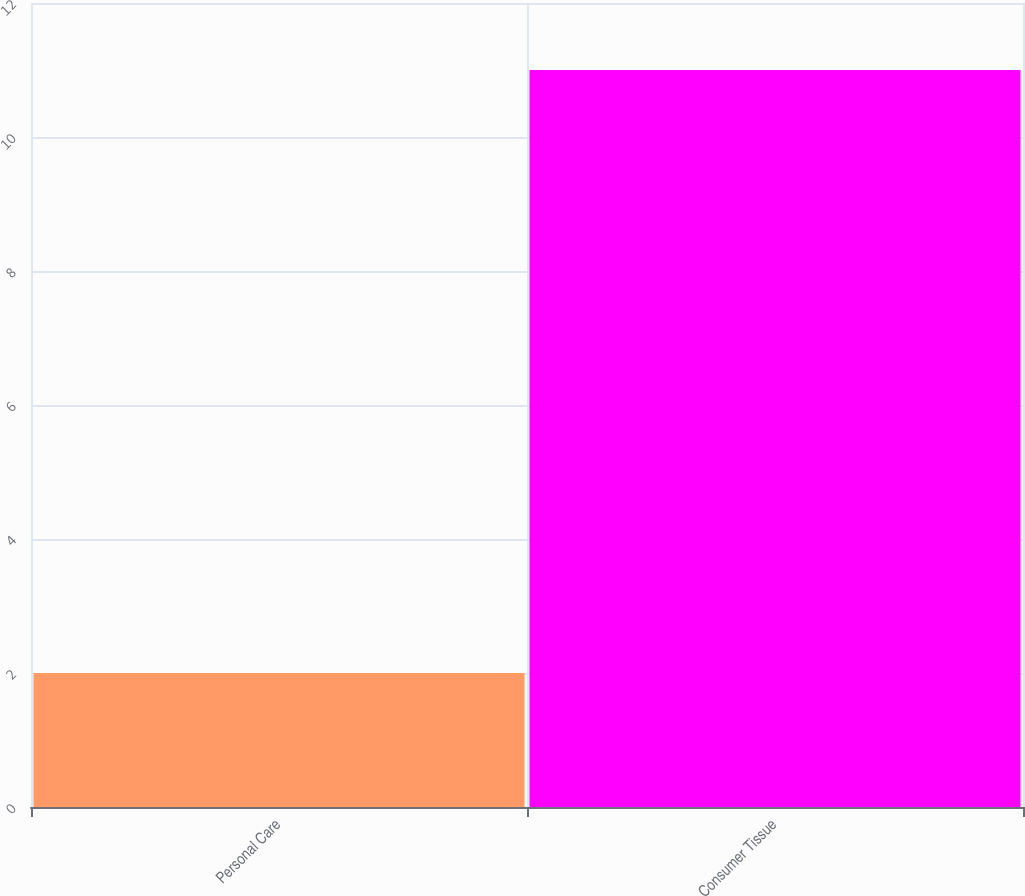Convert chart. <chart><loc_0><loc_0><loc_500><loc_500><bar_chart><fcel>Personal Care<fcel>Consumer Tissue<nl><fcel>2<fcel>11<nl></chart> 